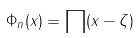<formula> <loc_0><loc_0><loc_500><loc_500>\Phi _ { n } ( x ) = \prod ( x - \zeta )</formula> 